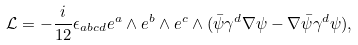<formula> <loc_0><loc_0><loc_500><loc_500>\mathcal { L } = - \frac { i } { 1 2 } \epsilon _ { a b c d } e ^ { a } \wedge e ^ { b } \wedge e ^ { c } \wedge ( \bar { \psi } \gamma ^ { d } \nabla \psi - \nabla \bar { \psi } \gamma ^ { d } \psi ) ,</formula> 